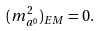<formula> <loc_0><loc_0><loc_500><loc_500>( m _ { a ^ { 0 } } ^ { 2 } ) _ { E M } = 0 .</formula> 